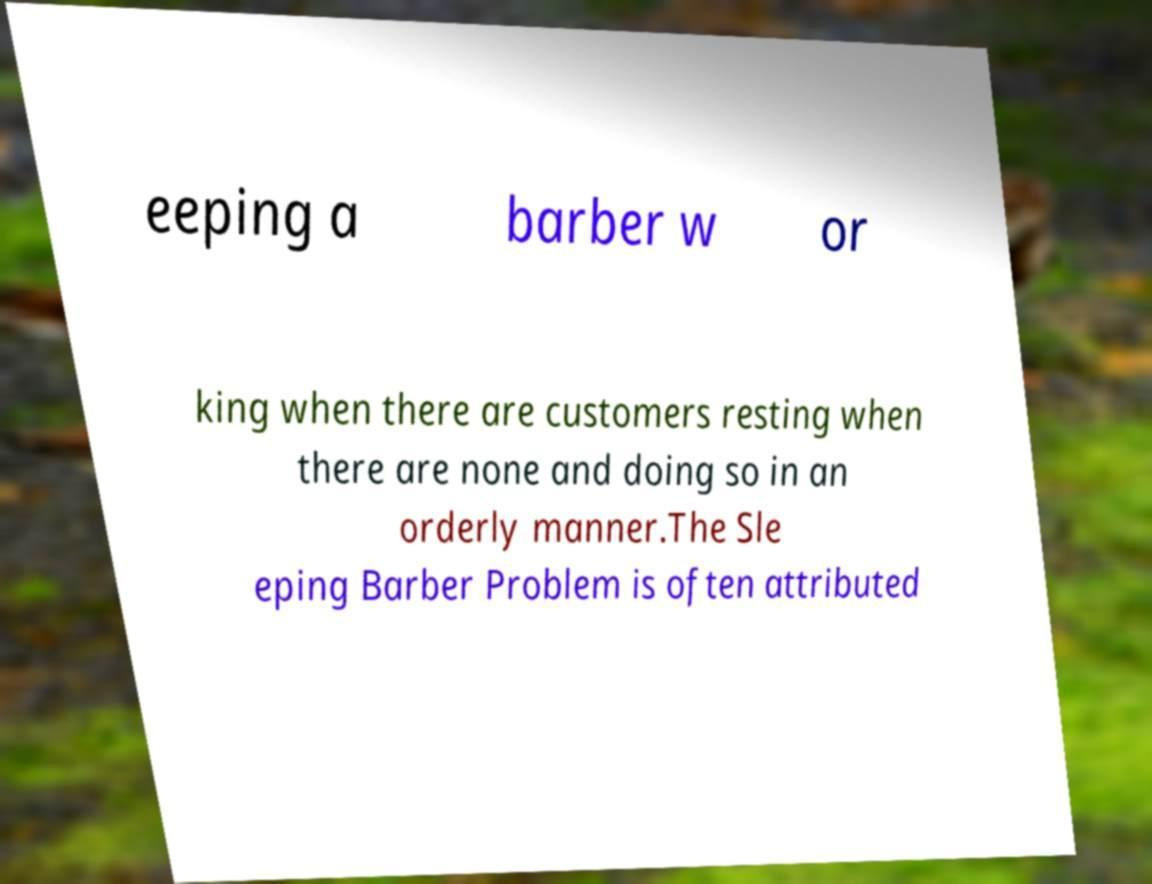What messages or text are displayed in this image? I need them in a readable, typed format. eeping a barber w or king when there are customers resting when there are none and doing so in an orderly manner.The Sle eping Barber Problem is often attributed 